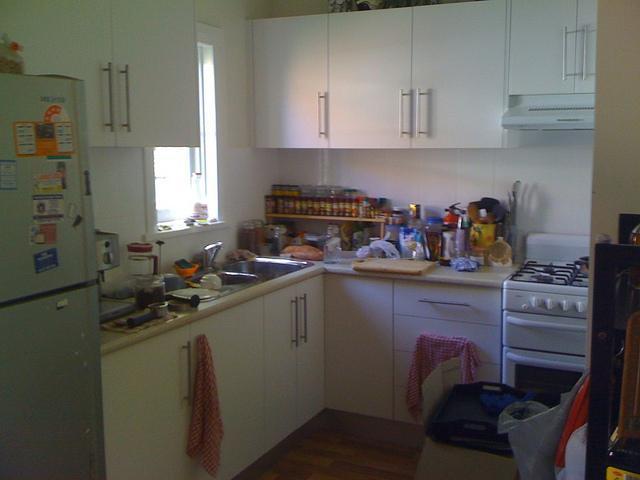How many bottles are currently open?
Give a very brief answer. 0. 